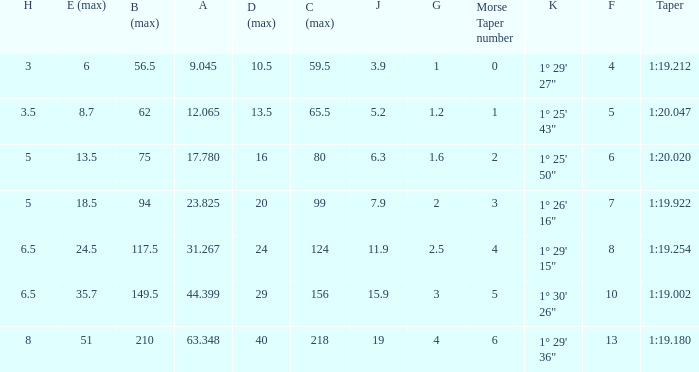Identify the h when c maximum is 99 5.0. 